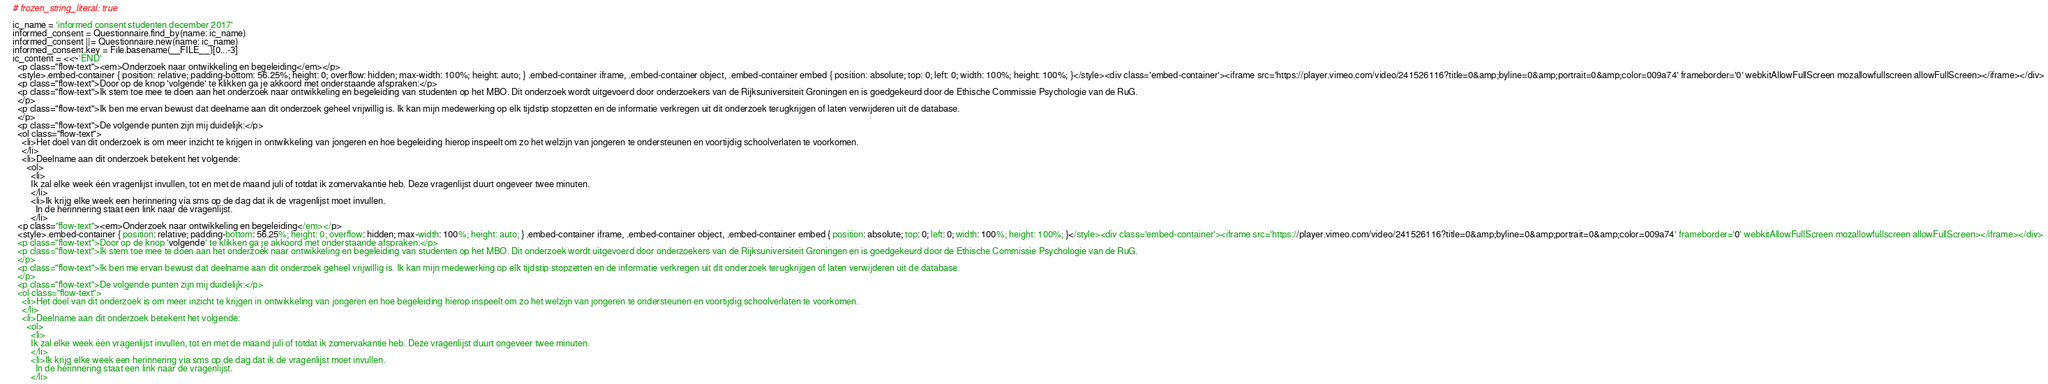<code> <loc_0><loc_0><loc_500><loc_500><_Ruby_># frozen_string_literal: true

ic_name = 'informed consent studenten december 2017'
informed_consent = Questionnaire.find_by(name: ic_name)
informed_consent ||= Questionnaire.new(name: ic_name)
informed_consent.key = File.basename(__FILE__)[0...-3]
ic_content = <<~'END'
  <p class="flow-text"><em>Onderzoek naar ontwikkeling en begeleiding</em></p>
  <style>.embed-container { position: relative; padding-bottom: 56.25%; height: 0; overflow: hidden; max-width: 100%; height: auto; } .embed-container iframe, .embed-container object, .embed-container embed { position: absolute; top: 0; left: 0; width: 100%; height: 100%; }</style><div class='embed-container'><iframe src='https://player.vimeo.com/video/241526116?title=0&amp;byline=0&amp;portrait=0&amp;color=009a74' frameborder='0' webkitAllowFullScreen mozallowfullscreen allowFullScreen></iframe></div>
  <p class="flow-text">Door op de knop 'volgende' te klikken ga je akkoord met onderstaande afspraken:</p>
  <p class="flow-text">Ik stem toe mee te doen aan het onderzoek naar ontwikkeling en begeleiding van studenten op het MBO. Dit onderzoek wordt uitgevoerd door onderzoekers van de Rijksuniversiteit Groningen en is goedgekeurd door de Ethische Commissie Psychologie van de RuG.
  </p>
  <p class="flow-text">Ik ben me ervan bewust dat deelname aan dit onderzoek geheel vrijwillig is. Ik kan mijn medewerking op elk tijdstip stopzetten en de informatie verkregen uit dit onderzoek terugkrijgen of laten verwijderen uit de database.
  </p>
  <p class="flow-text">De volgende punten zijn mij duidelijk:</p>
  <ol class="flow-text">
    <li>Het doel van dit onderzoek is om meer inzicht te krijgen in ontwikkeling van jongeren en hoe begeleiding hierop inspeelt om zo het welzijn van jongeren te ondersteunen en voortijdig schoolverlaten te voorkomen.
    </li>
    <li>Deelname aan dit onderzoek betekent het volgende:
      <ol>
        <li>
        Ik zal elke week één vragenlijst invullen, tot en met de maand juli of totdat ik zomervakantie heb. Deze vragenlijst duurt ongeveer twee minuten.
        </li>
        <li>Ik krijg elke week een herinnering via sms op de dag dat ik de vragenlijst moet invullen.
          In de herinnering staat een link naar de vragenlijst.
        </li></code> 